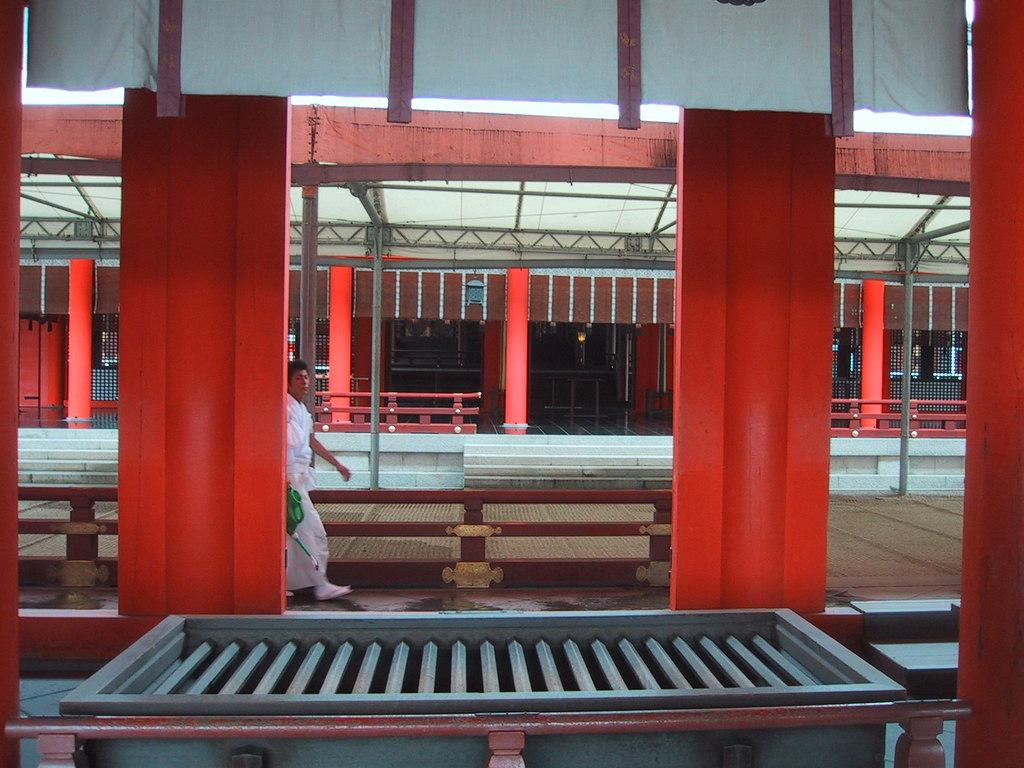What is the person in the image doing? The person is walking in the image. What is the person wearing? The person is wearing a white and red outfit. What can be seen in the background of the image? There is a building in the background of the image. What is a notable feature of the building? The building has red pillars. What type of profit is the person making while walking in the image? There is no mention of profit or any financial activity in the image; the person is simply walking. 